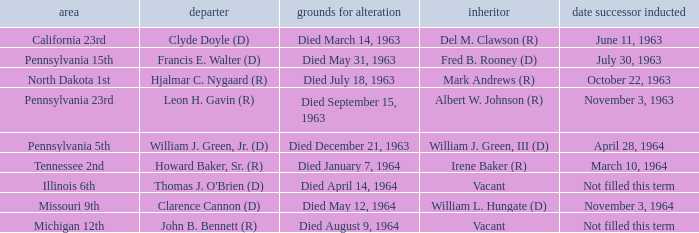What is every district for reason for change is died August 9, 1964? Michigan 12th. 